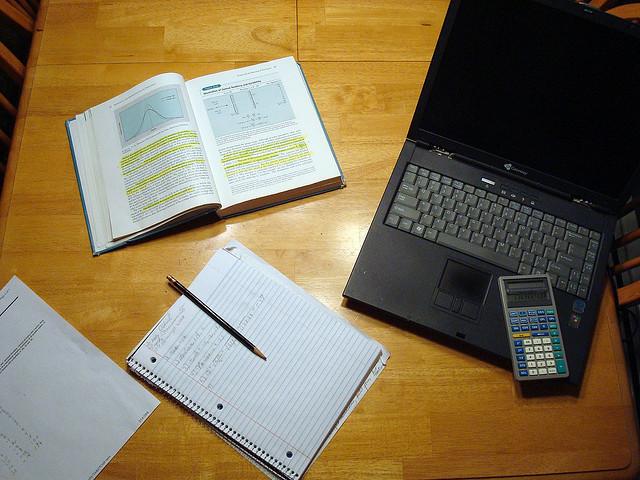Is there a mouse?
Short answer required. No. Is the comp on?
Give a very brief answer. No. Why is part of the text in the book yellow?
Be succinct. Highlighted. What do you call these two devices?
Be succinct. Calculator and laptop. Is there a cup of coffee on the table?
Write a very short answer. No. 